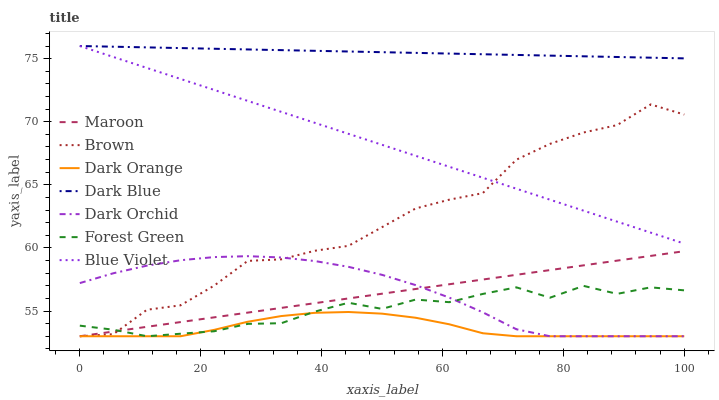Does Dark Orange have the minimum area under the curve?
Answer yes or no. Yes. Does Dark Blue have the maximum area under the curve?
Answer yes or no. Yes. Does Dark Orchid have the minimum area under the curve?
Answer yes or no. No. Does Dark Orchid have the maximum area under the curve?
Answer yes or no. No. Is Maroon the smoothest?
Answer yes or no. Yes. Is Brown the roughest?
Answer yes or no. Yes. Is Dark Orange the smoothest?
Answer yes or no. No. Is Dark Orange the roughest?
Answer yes or no. No. Does Brown have the lowest value?
Answer yes or no. Yes. Does Dark Blue have the lowest value?
Answer yes or no. No. Does Blue Violet have the highest value?
Answer yes or no. Yes. Does Dark Orchid have the highest value?
Answer yes or no. No. Is Forest Green less than Dark Blue?
Answer yes or no. Yes. Is Blue Violet greater than Dark Orange?
Answer yes or no. Yes. Does Blue Violet intersect Dark Blue?
Answer yes or no. Yes. Is Blue Violet less than Dark Blue?
Answer yes or no. No. Is Blue Violet greater than Dark Blue?
Answer yes or no. No. Does Forest Green intersect Dark Blue?
Answer yes or no. No. 